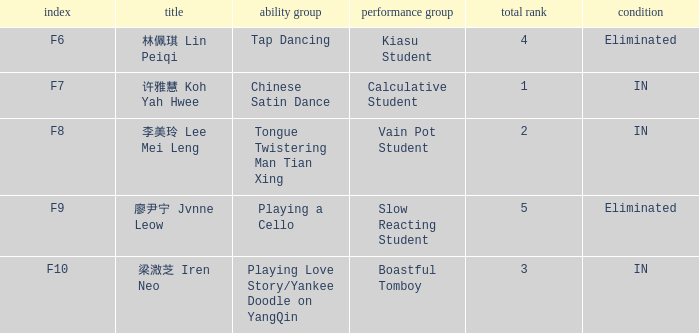For the event with index f9, what's the talent segment? Playing a Cello. 